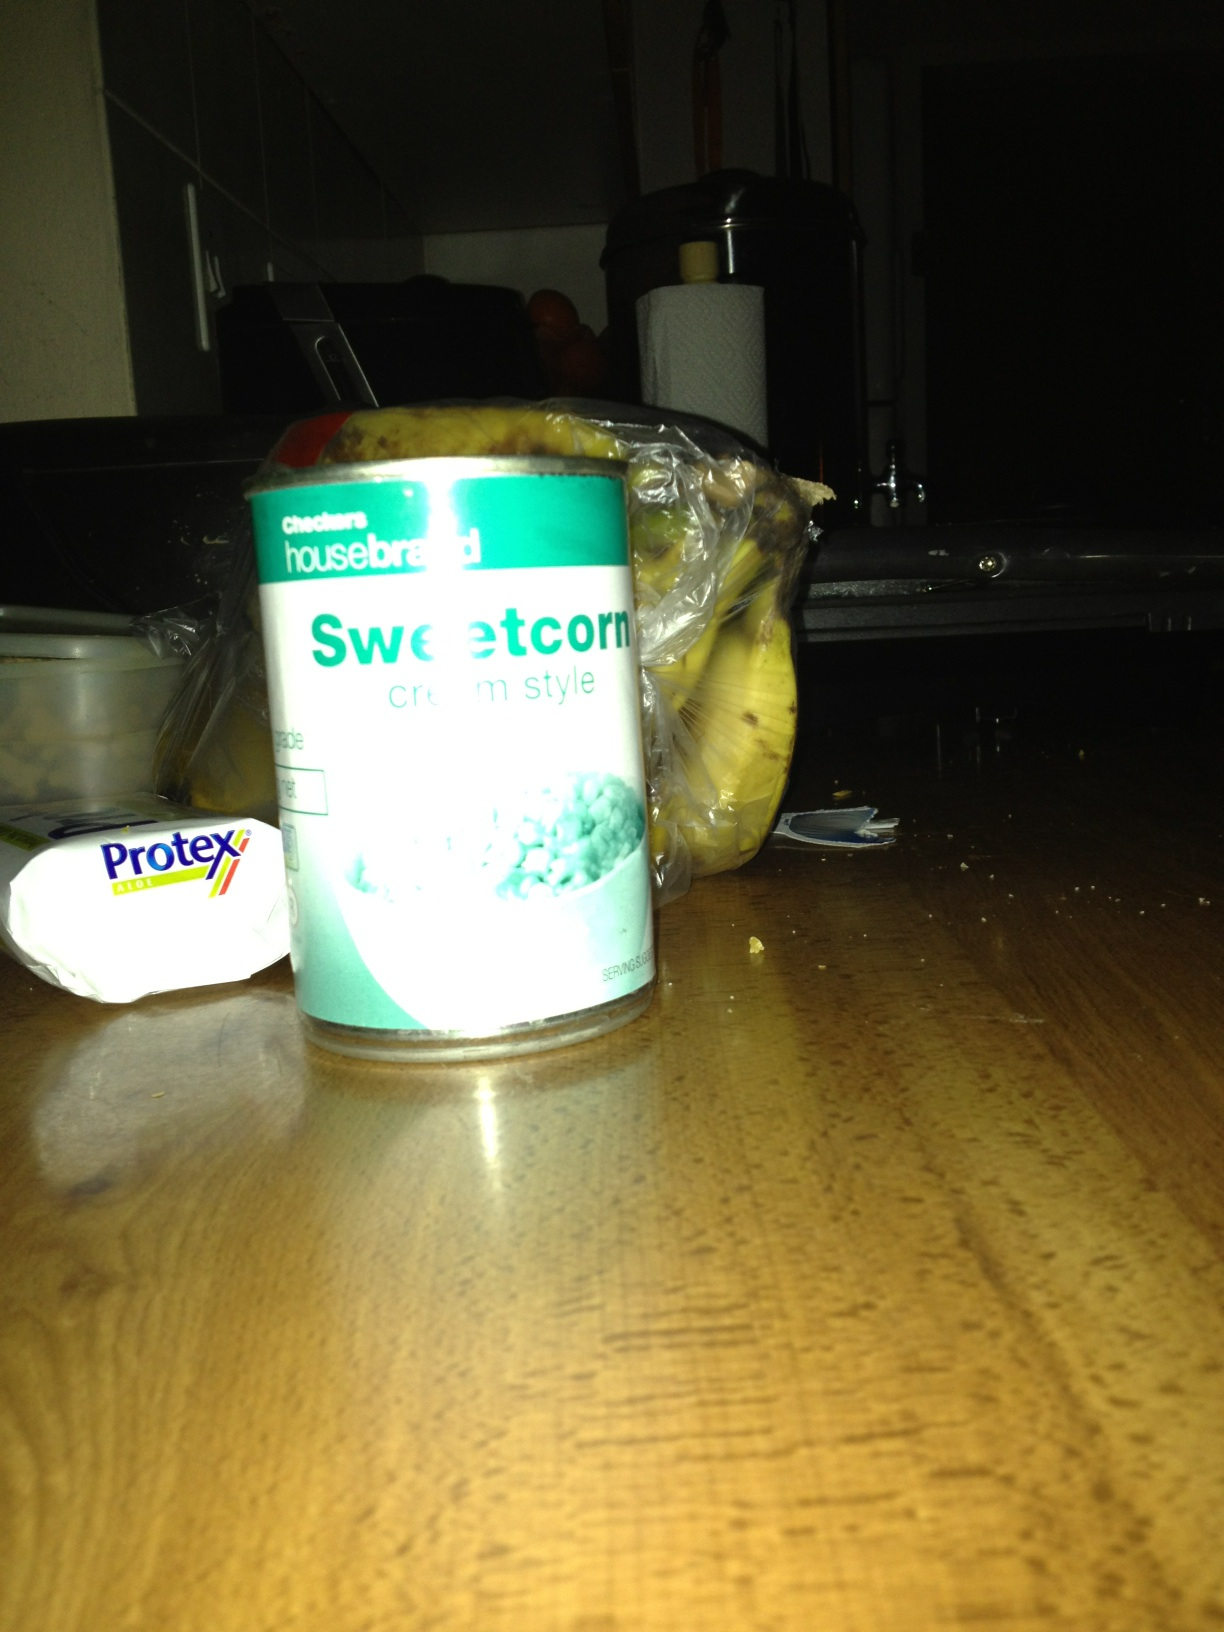What is in the can? The can contains sweetcorn, specifically of the cream style variety. 